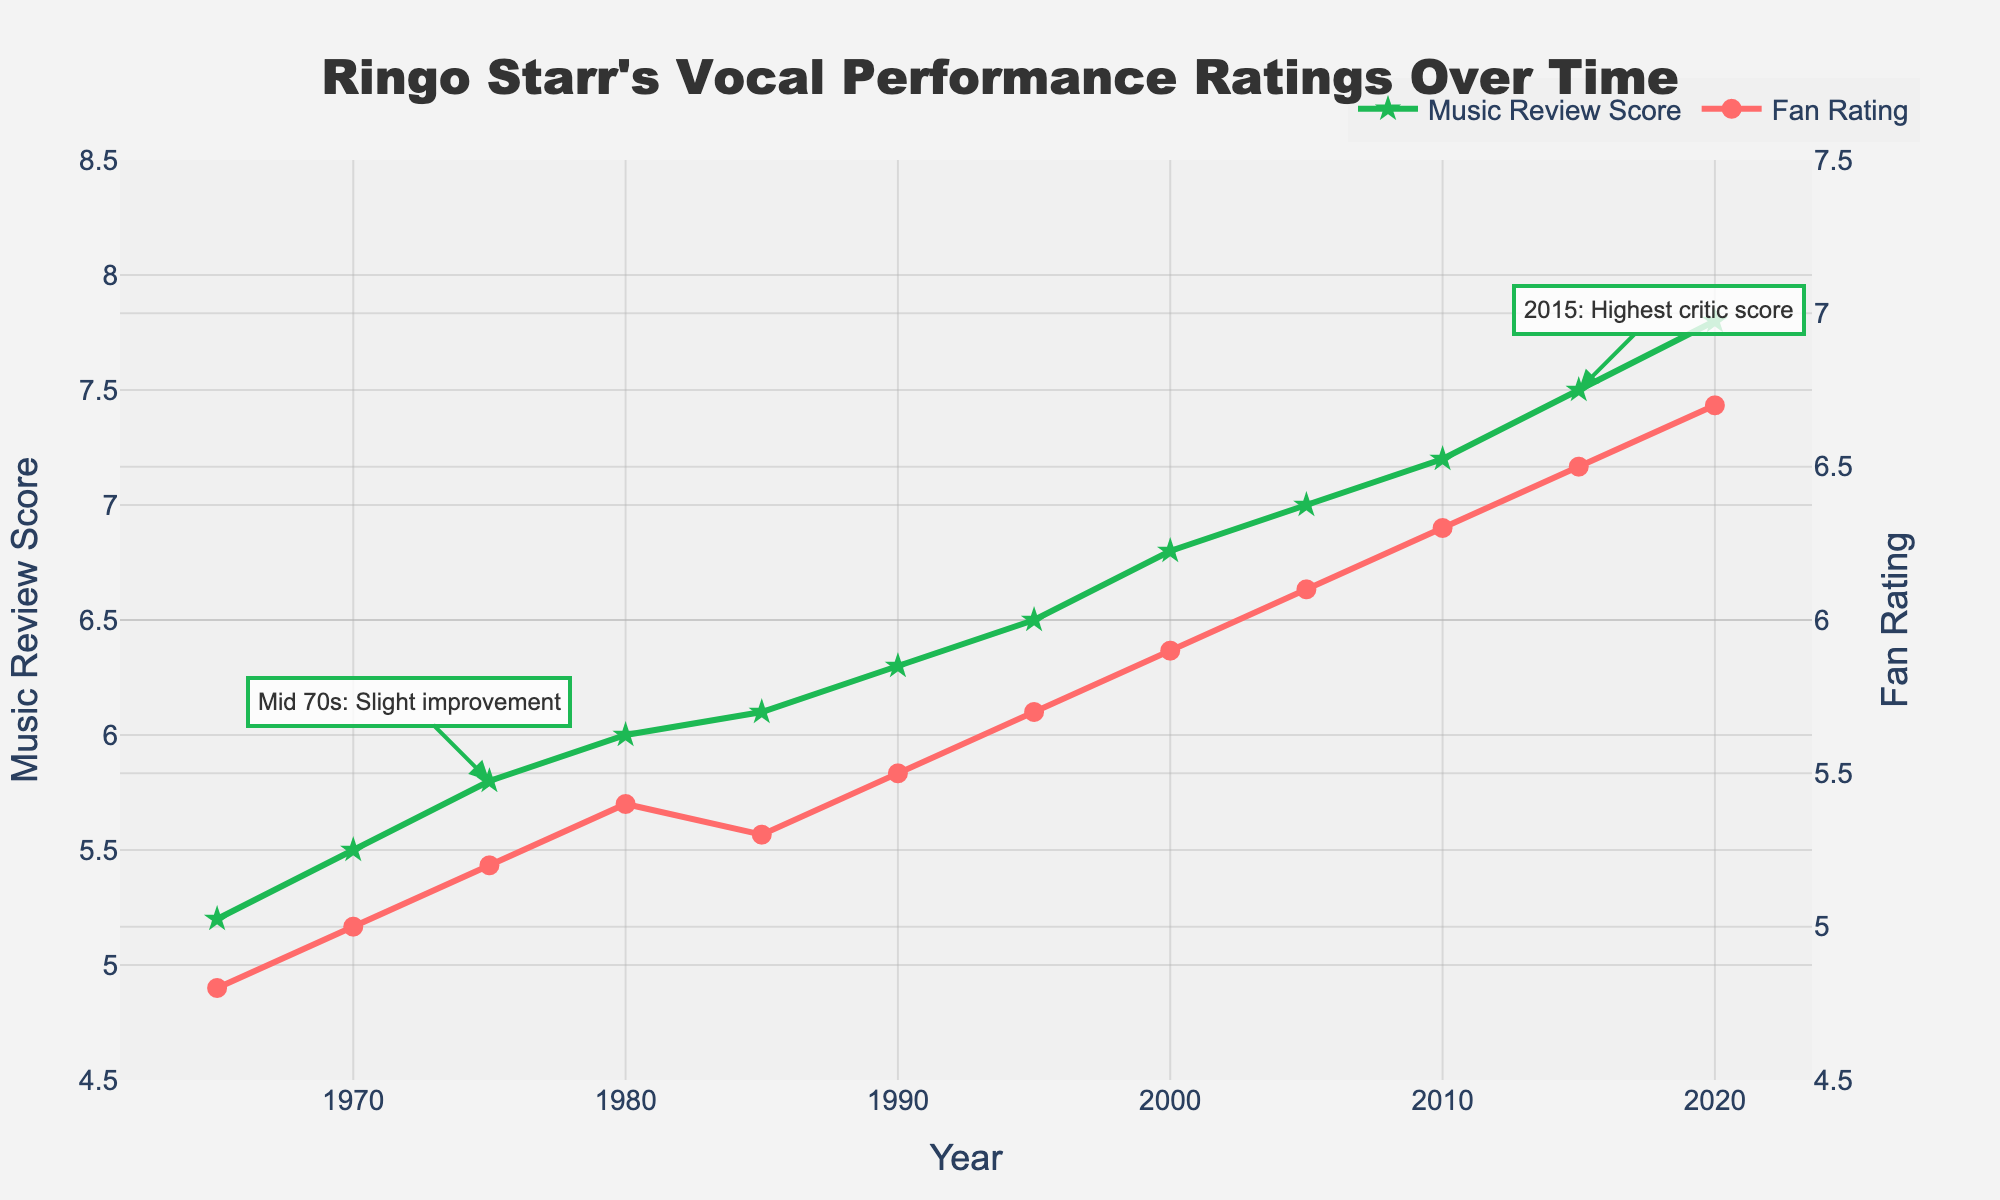What's the title of the plot? The title is located at the top of the plot and describes what the plot is about. It reads, "Ringo Starr's Vocal Performance Ratings Over Time."
Answer: Ringo Starr's Vocal Performance Ratings Over Time How many data points are presented for fan ratings? The fan ratings are displayed using circles on the plot. Counting these, we find there are 12 data points, from 1965 to 2020.
Answer: 12 Which year had the highest music review score, and what was the score? The highest music review score can be identified by looking for the peak on the green line with star markers. It's at 2015, with a score of 7.5.
Answer: 2015, 7.5 When did the fan rating first exceed 6? To determine this, observe the red line with circle markers and find the first point where the value exceeds 6. This happens in the year 2000.
Answer: 2000 What's the difference between the music review score and fan rating in 1985? Subtract the fan rating value from the music review score value in 1985 (6.1 - 5.3). This will give the difference.
Answer: 0.8 During which year did both the music review score and fan rating show an increase from the previous point? This involves checking both lines and finding where both lines increase simultaneously. Comparing adjacent points, it happens between 2000 and 2005.
Answer: 2005 What is the average fan rating from 2000 to 2020? Add up the fan ratings for the years 2000 to 2020 (5.9 + 6.1 + 6.3 + 6.5 + 6.7) and then divide by the number of years (5). (5.9 + 6.1 + 6.3 + 6.5 + 6.7) / 5 = 31.5 / 5 = 6.3
Answer: 6.3 Which source provided the highest music review score? Look at the highest point in the green line and read the annotation or reference next to that point. It is Rolling Stone in 2015.
Answer: Rolling Stone What's the overall trend observed in the fan ratings from 1965 to 2020? Observing the red line (fan ratings) from the start to the end of the chart, it shows a general upward trend, indicating improvement over time.
Answer: Upward trend How many times did the fan rating decrease over consecutive periods? Check the fan rating line for any downward slopes between consecutive points over time. The line shows a decrease from 1985 to 1990 and 1980 to 1985, which counts as two periods.
Answer: 2 